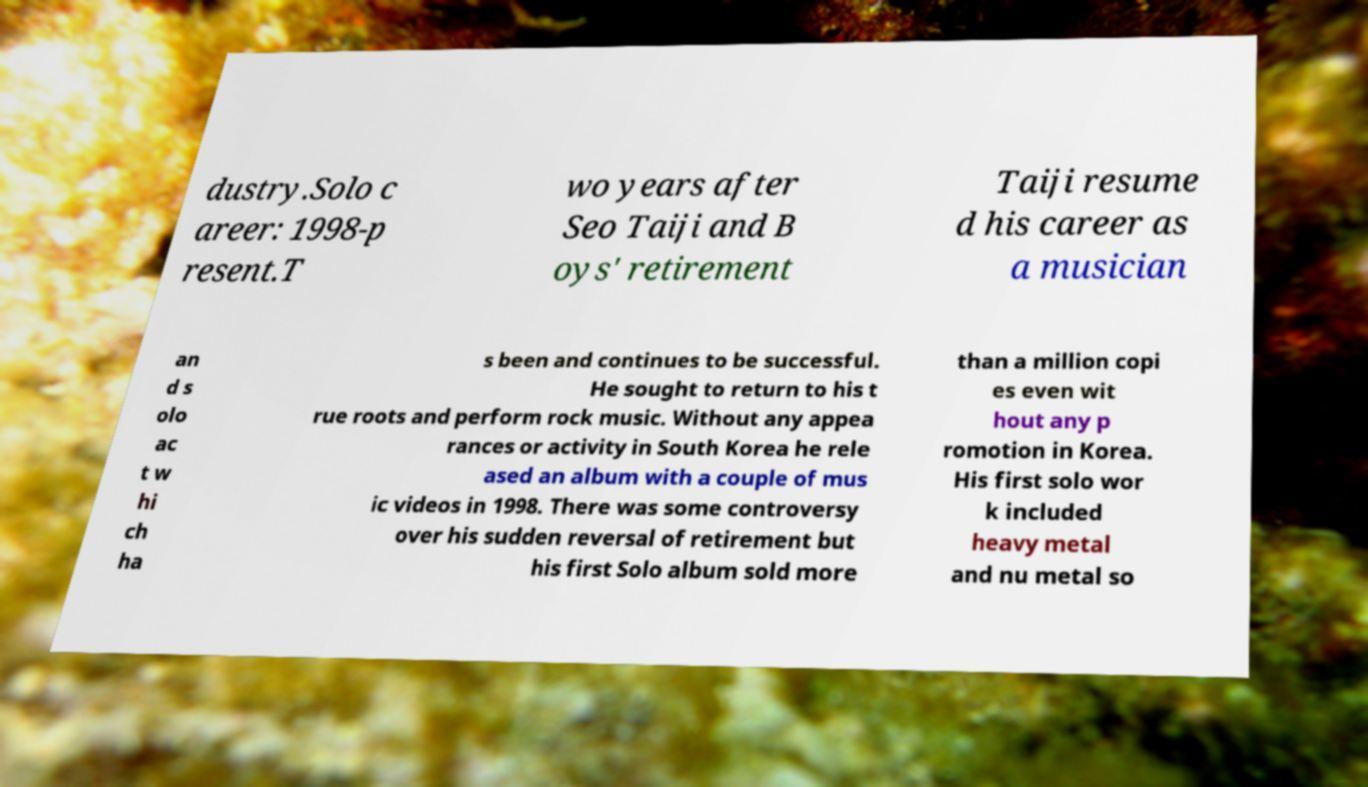Can you read and provide the text displayed in the image?This photo seems to have some interesting text. Can you extract and type it out for me? dustry.Solo c areer: 1998-p resent.T wo years after Seo Taiji and B oys' retirement Taiji resume d his career as a musician an d s olo ac t w hi ch ha s been and continues to be successful. He sought to return to his t rue roots and perform rock music. Without any appea rances or activity in South Korea he rele ased an album with a couple of mus ic videos in 1998. There was some controversy over his sudden reversal of retirement but his first Solo album sold more than a million copi es even wit hout any p romotion in Korea. His first solo wor k included heavy metal and nu metal so 